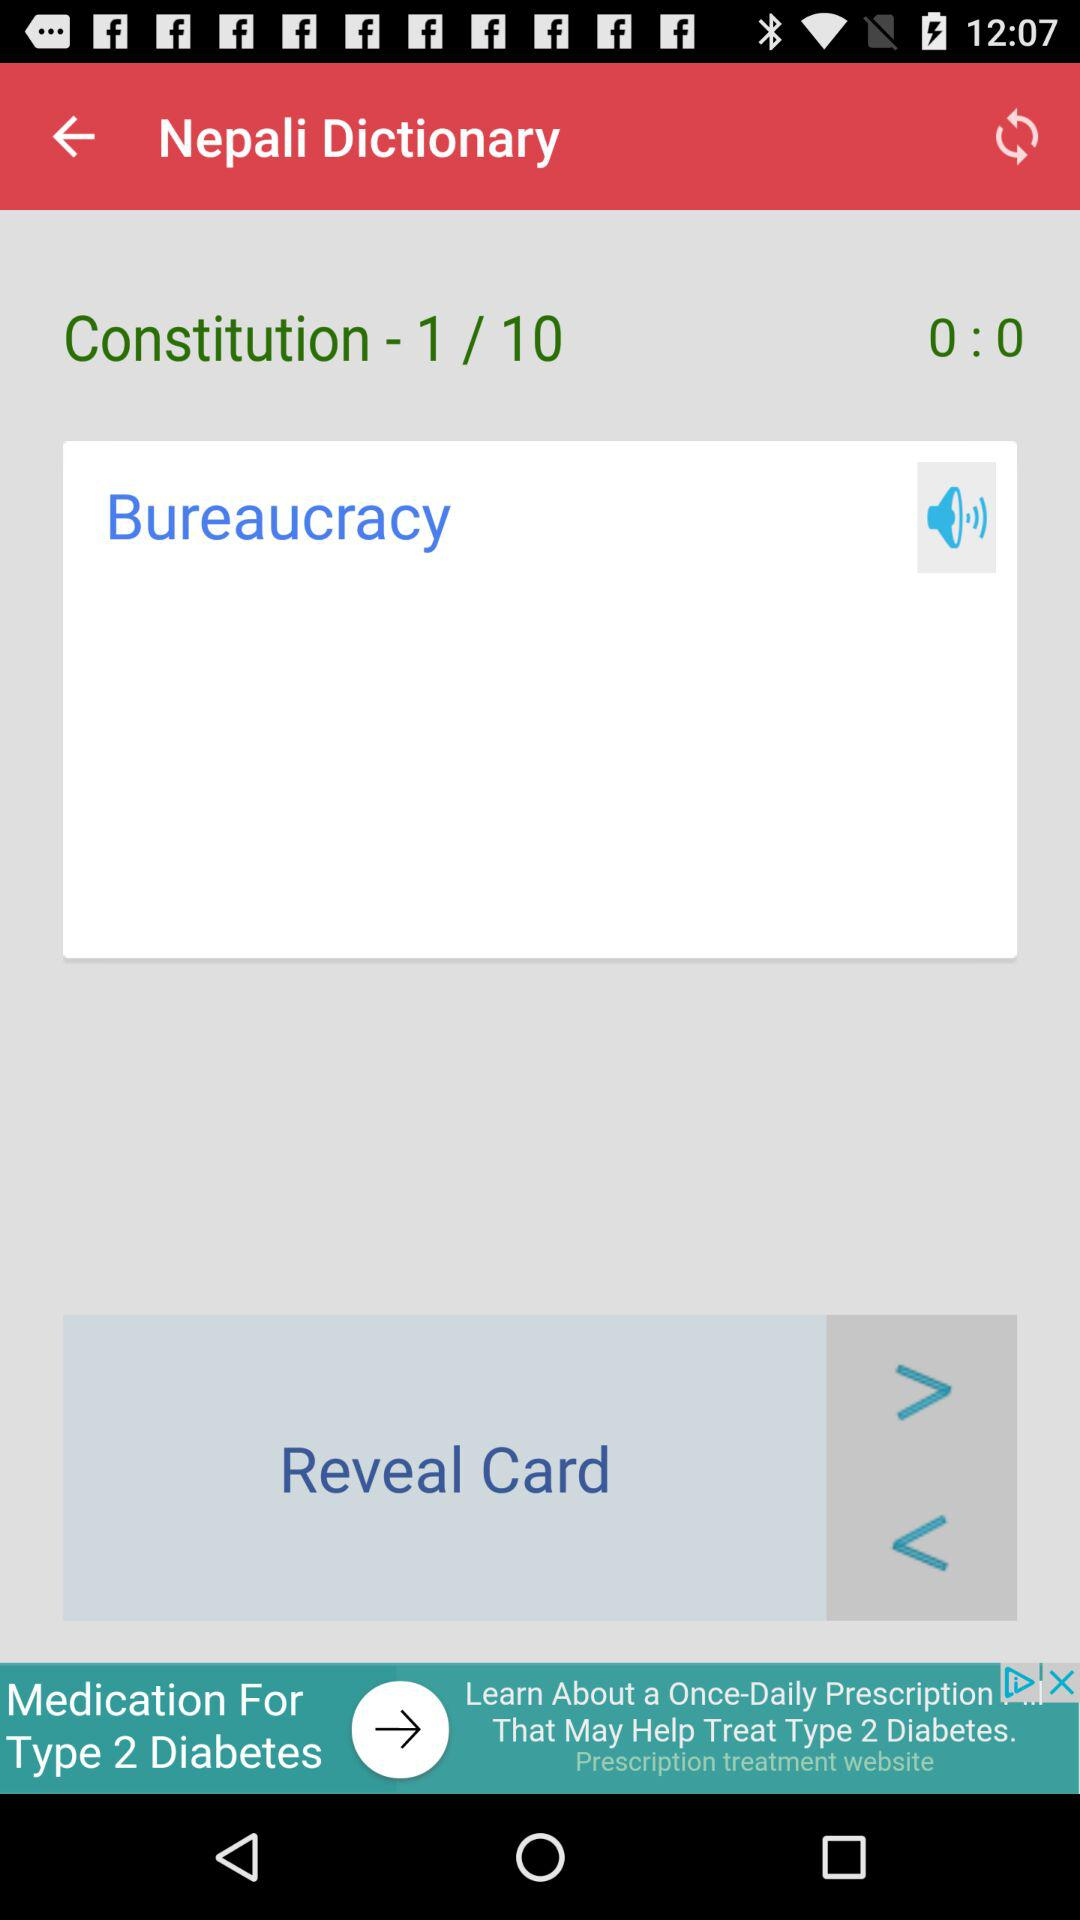At which constitution out of 10 are we? You are at the first constitution. 